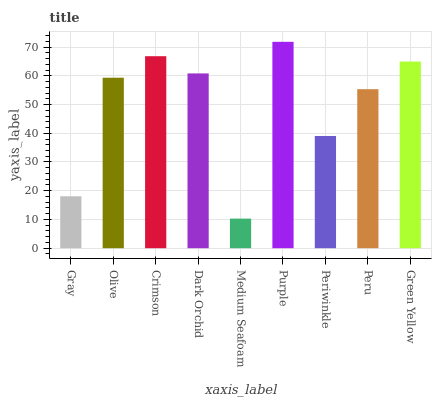Is Olive the minimum?
Answer yes or no. No. Is Olive the maximum?
Answer yes or no. No. Is Olive greater than Gray?
Answer yes or no. Yes. Is Gray less than Olive?
Answer yes or no. Yes. Is Gray greater than Olive?
Answer yes or no. No. Is Olive less than Gray?
Answer yes or no. No. Is Olive the high median?
Answer yes or no. Yes. Is Olive the low median?
Answer yes or no. Yes. Is Crimson the high median?
Answer yes or no. No. Is Peru the low median?
Answer yes or no. No. 